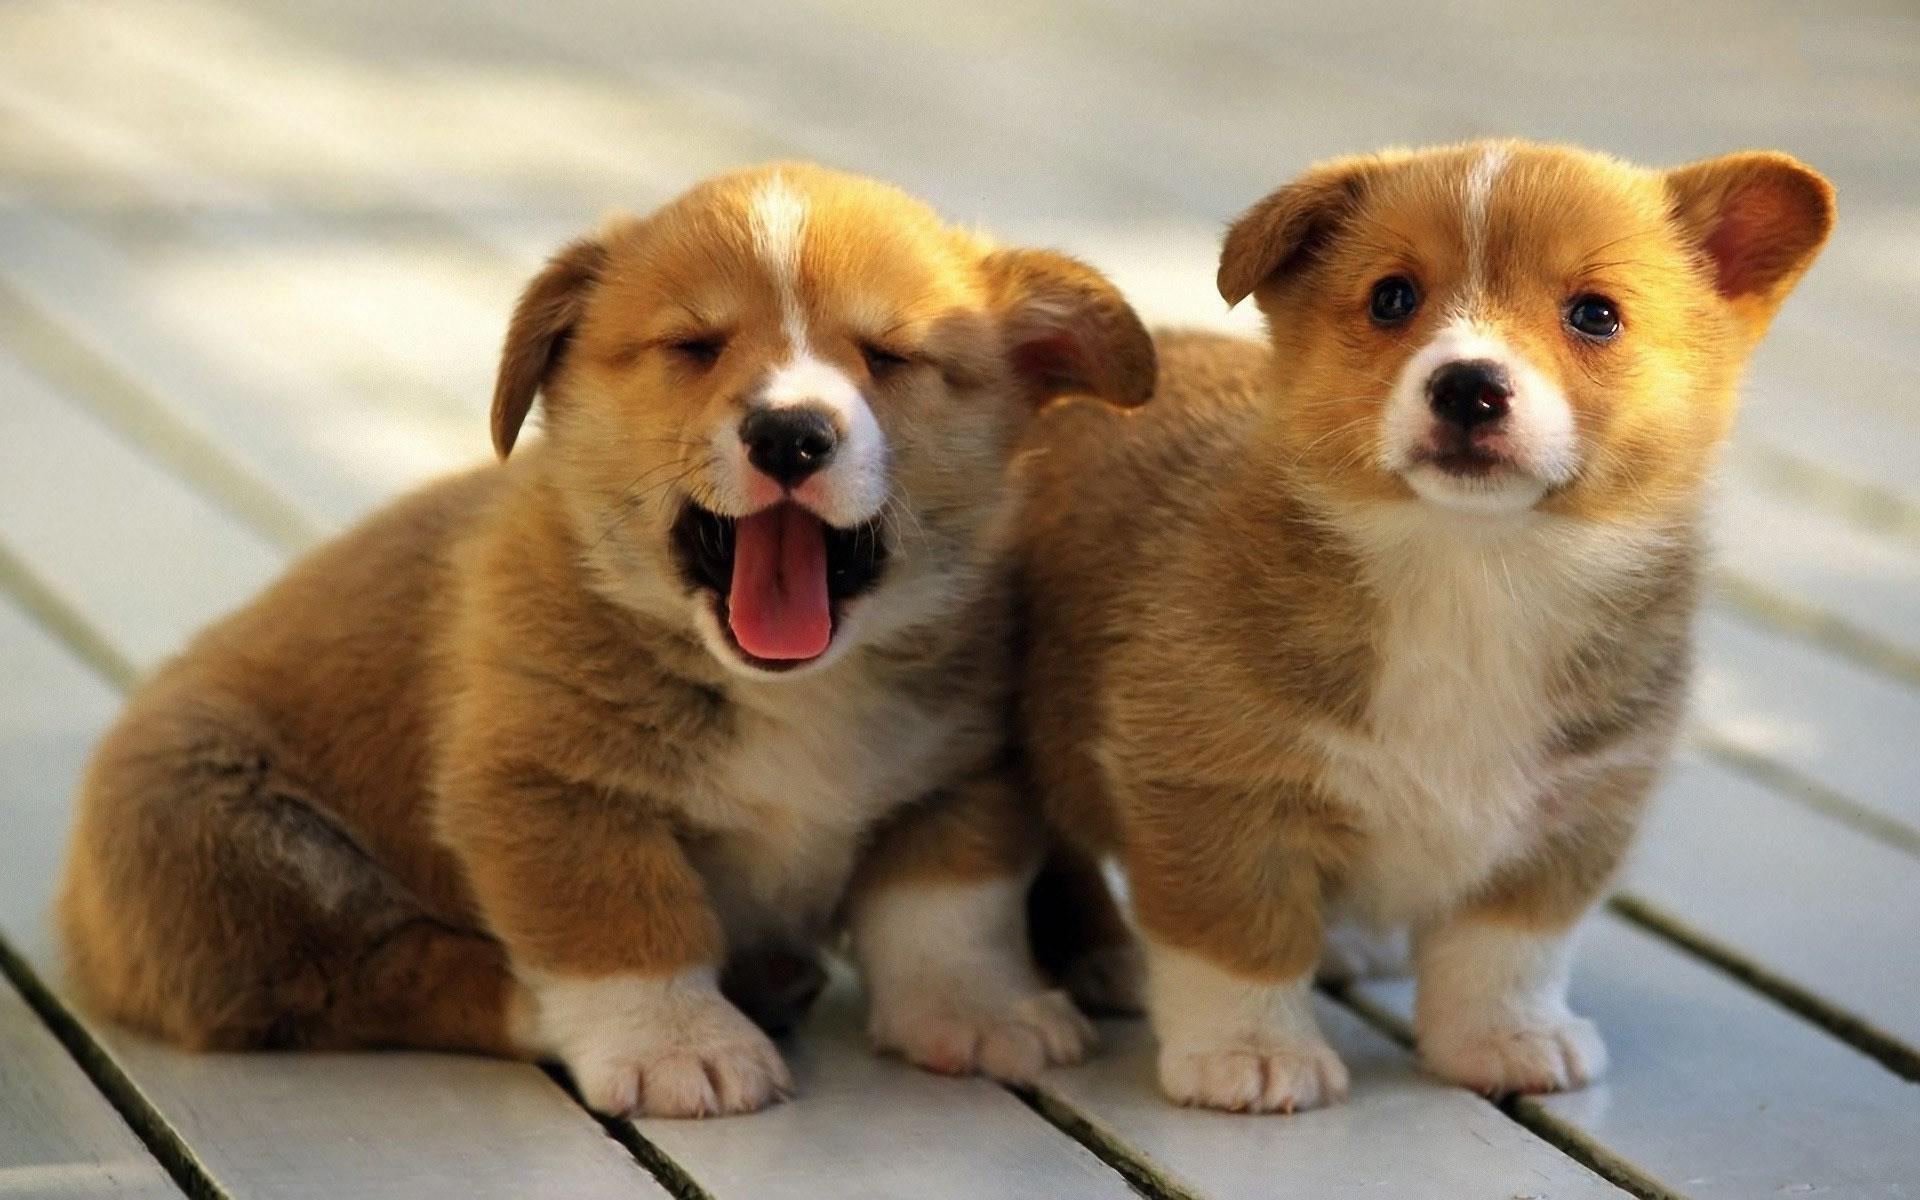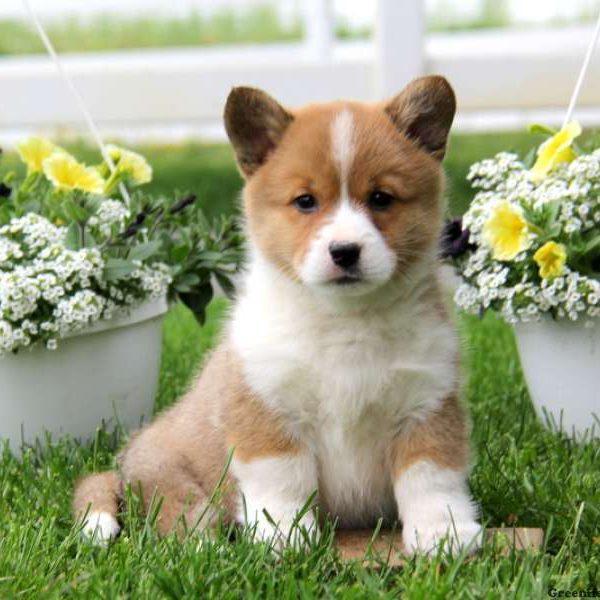The first image is the image on the left, the second image is the image on the right. Assess this claim about the two images: "One puppy is sitting in each image.". Correct or not? Answer yes or no. Yes. 